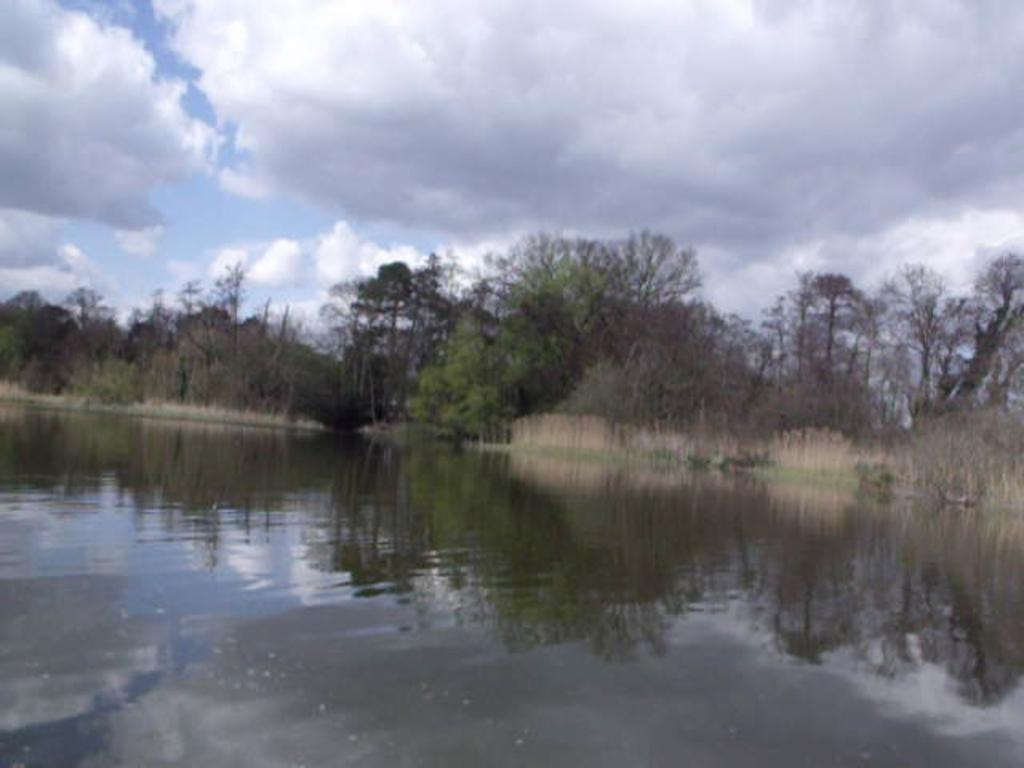What is visible in the front of the image? There is water in the front of the image. What can be seen in the background of the image? There are trees in the background of the image. How would you describe the sky in the image? The sky is cloudy in the image. What type of sock is hanging from the tree in the image? There is no sock present in the image; it features water, trees, and a cloudy sky. Is there a party happening in the image? There is no indication of a party in the image; it simply shows water, trees, and a cloudy sky. 